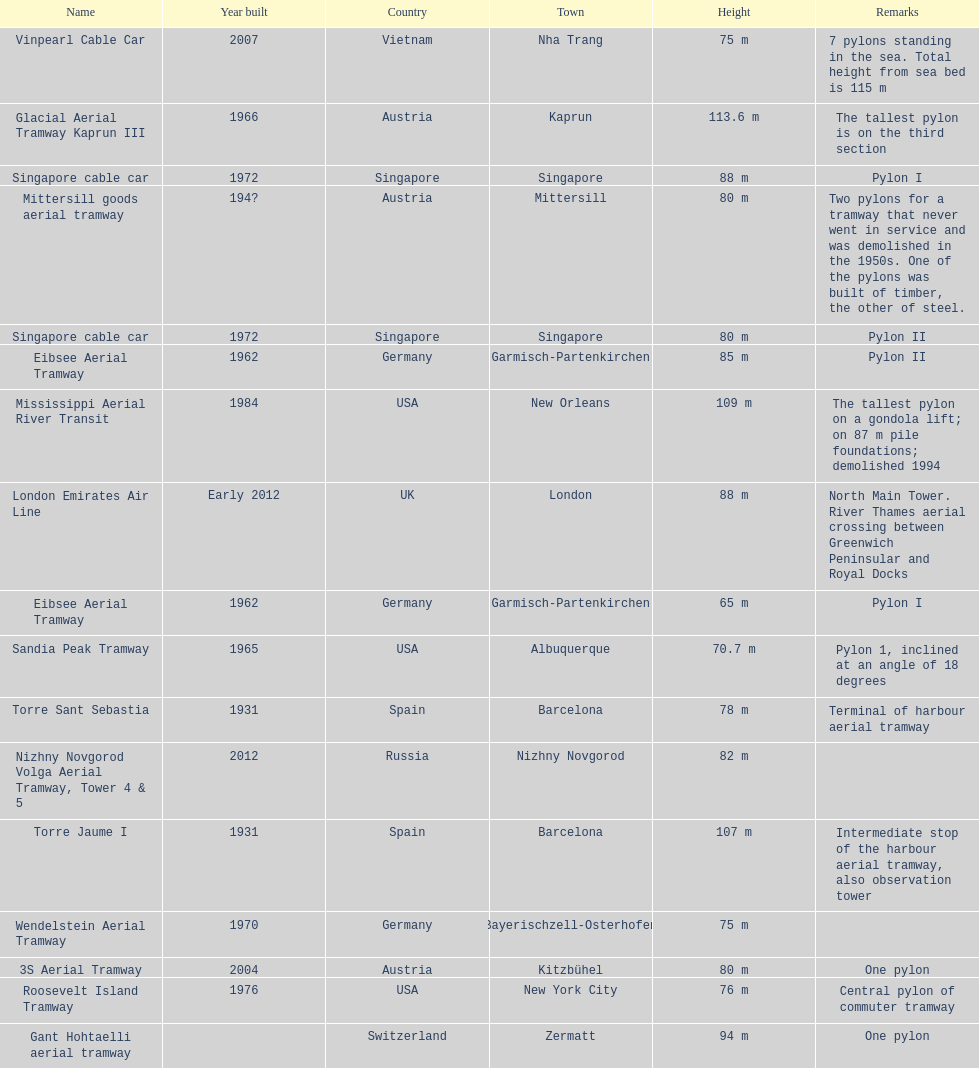How many pylons are in austria? 3. 